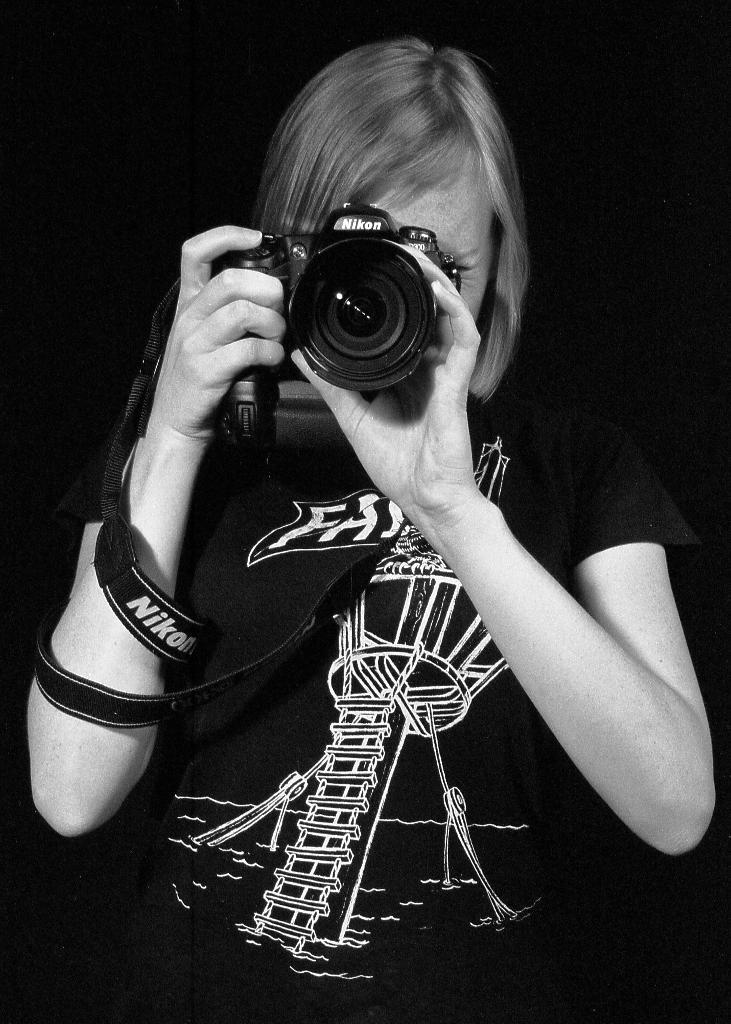Who is the main subject in the image? There is a woman in the image. What is the woman holding in the image? The woman is holding a camera. What type of secretary is the woman in the image? There is no indication in the image that the woman is a secretary, as she is holding a camera. 